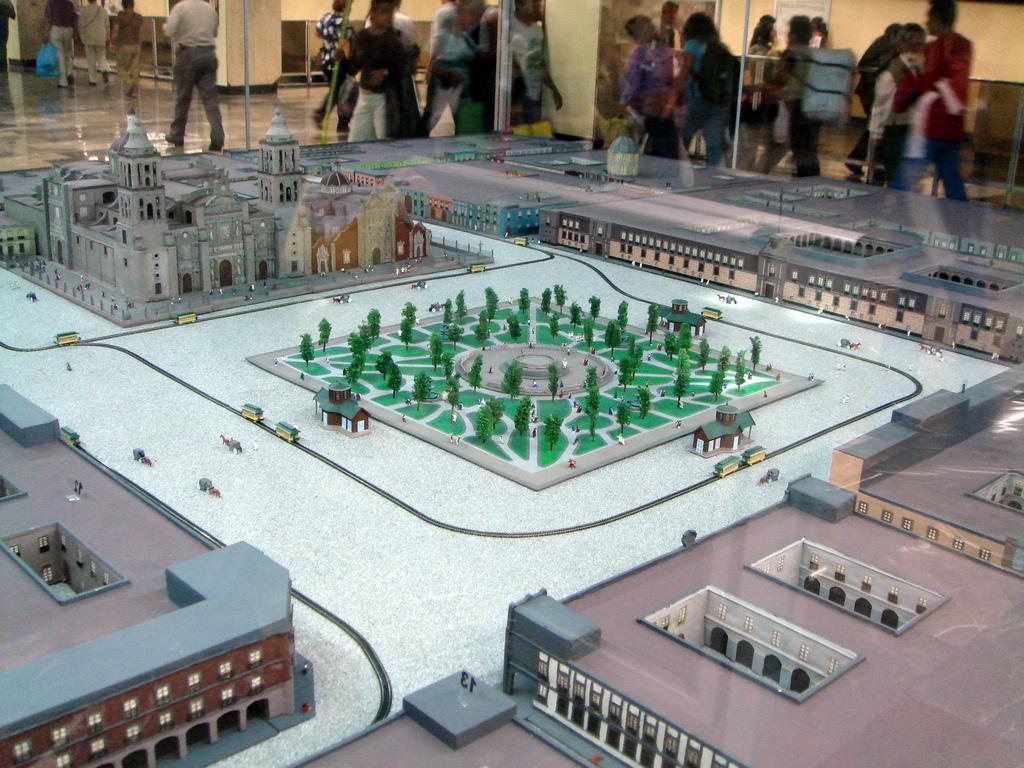How would you summarize this image in a sentence or two? In this image I can see trees, buildings and vehicles made up of papers kept for showcase. In the background I can see a crowd on the floor, poles, board and a wall. This image is taken may be in a museum during a day. 